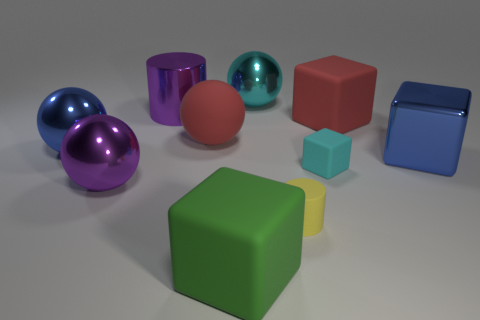Subtract all big blocks. How many blocks are left? 1 Subtract 2 cubes. How many cubes are left? 2 Subtract all brown spheres. Subtract all yellow cylinders. How many spheres are left? 4 Subtract all balls. How many objects are left? 6 Subtract 0 gray spheres. How many objects are left? 10 Subtract all small brown shiny cubes. Subtract all cyan things. How many objects are left? 8 Add 3 cyan things. How many cyan things are left? 5 Add 6 tiny blocks. How many tiny blocks exist? 7 